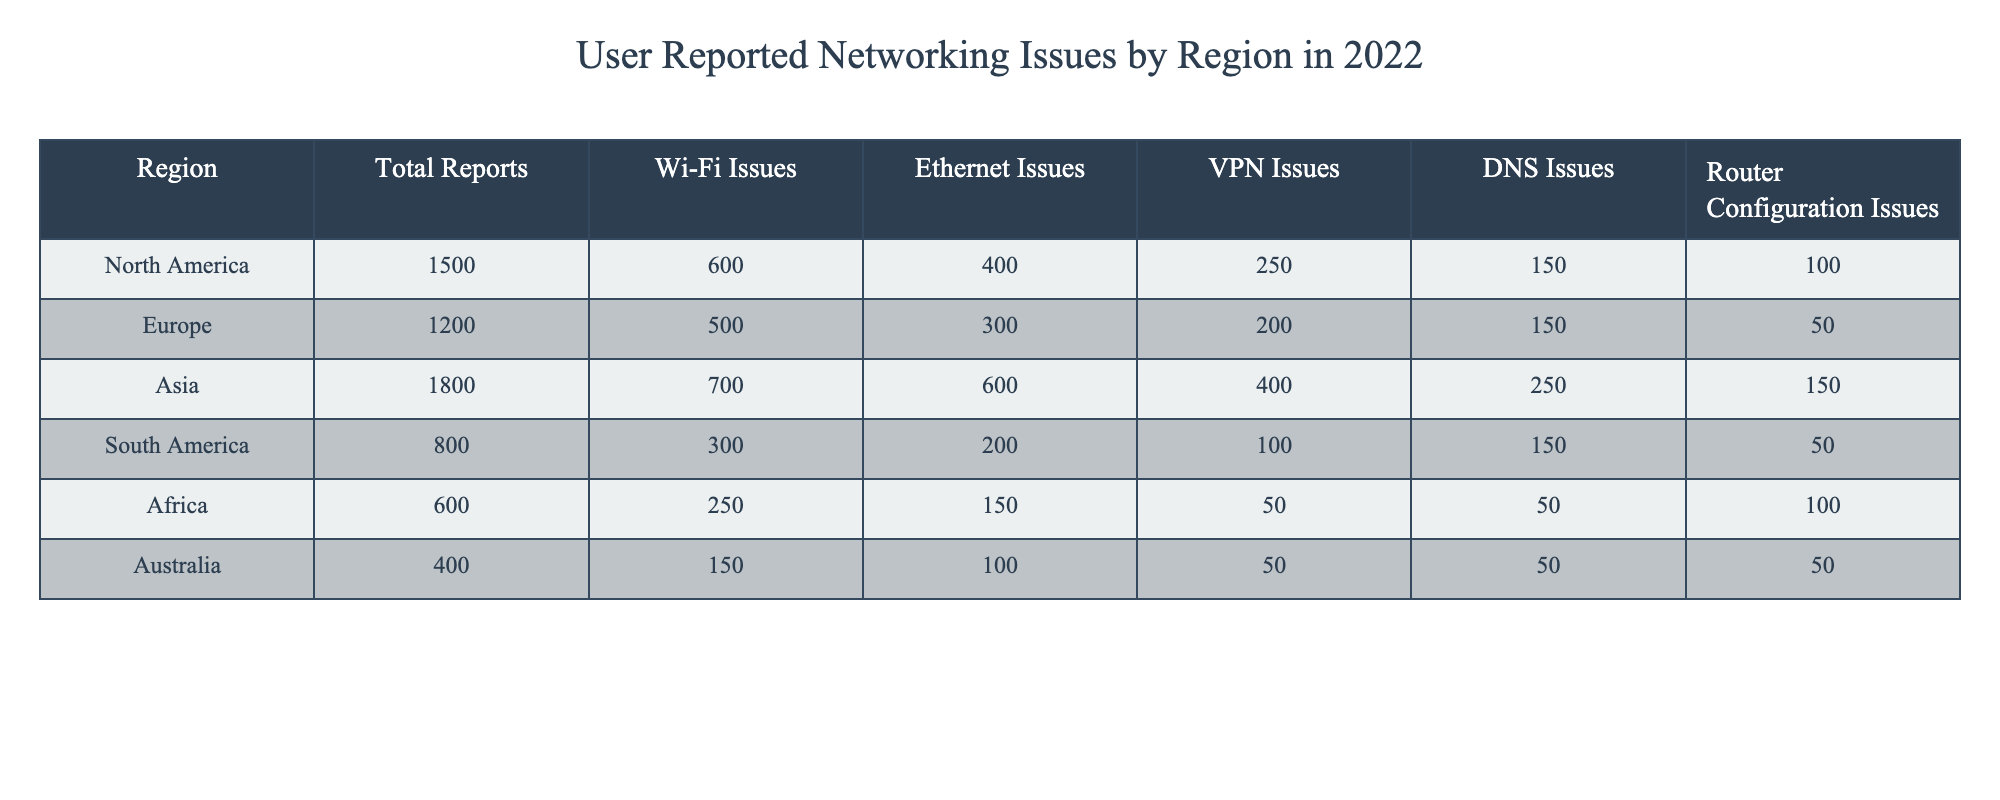What region reported the highest total number of networking issues? By examining the "Total Reports" column, North America has the highest value at 1500.
Answer: North America How many Wi-Fi issues were reported in Asia? The "Wi-Fi Issues" column for Asia shows a value of 700.
Answer: 700 What is the total count of Ethernet issues reported across all regions? Adding up the values in the "Ethernet Issues" column (400 + 300 + 600 + 200 + 150 + 100) gives a total of 1850.
Answer: 1850 Is the number of VPN issues reported in South America greater than that reported in Africa? South America reported 100 VPN issues, while Africa reported 50. Thus, the statement is true.
Answer: Yes Which region experienced the least number of total reports? By observing the "Total Reports" column, Australia has the lowest value at 400.
Answer: Australia How many more DNS issues were reported in North America than in Australia? North America reported 150 DNS issues and Australia reported 50. The difference is 150 - 50 = 100.
Answer: 100 What region had the highest number of reports for router configuration issues? By checking the "Router Configuration Issues" column, North America has the highest total with 100 reported issues.
Answer: North America Which two regions had the same number of router configuration issues reported? Both Africa and Australia reported 50 router configuration issues each.
Answer: Africa and Australia What percentage of total reports in Europe were due to Wi-Fi issues? The percentage is calculated as (500 Wi-Fi issues / 1200 total reports) * 100 = 41.67%.
Answer: 41.67% Is there a region that reported more VPN issues than Ethernet issues? Comparing VPN and Ethernet Issues: Asia has 400 VPN issues against 600 Ethernet issues, while South America has 100 VPN against 200 Ethernet, Pacific counts lower than that. Thus, the answer is no.
Answer: No Which region showed the least variety in types of reported issues, based on the lowest maximum issue reported? Australia reported a maximum of 150 in Wi-Fi issues, whereas all other regions reported higher maximums for at least one type. Thus, Australia is the least varied.
Answer: Australia 